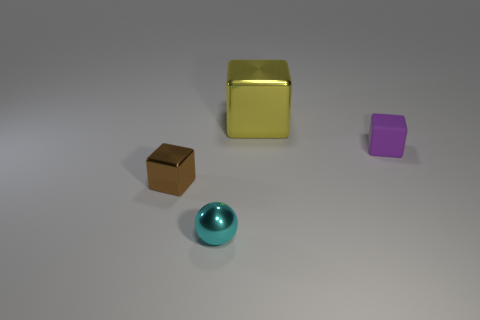Are there any other things that have the same size as the yellow metal cube?
Your response must be concise. No. Do the cube left of the tiny cyan ball and the cube that is behind the small rubber thing have the same material?
Offer a terse response. Yes. There is a object that is to the right of the shiny cube behind the cube on the left side of the cyan metal object; what is its shape?
Ensure brevity in your answer.  Cube. What number of small purple things have the same material as the tiny brown cube?
Provide a short and direct response. 0. What number of yellow blocks are left of the metal block to the right of the tiny brown object?
Your response must be concise. 0. What is the shape of the object that is both behind the brown metal object and in front of the large yellow shiny thing?
Make the answer very short. Cube. Is there another brown object that has the same shape as the large metal object?
Provide a succinct answer. Yes. There is a cyan metallic object that is the same size as the matte object; what is its shape?
Provide a short and direct response. Sphere. What is the material of the large object?
Make the answer very short. Metal. There is a cyan metal sphere that is in front of the metal block that is in front of the shiny thing that is behind the tiny purple rubber cube; what size is it?
Give a very brief answer. Small. 